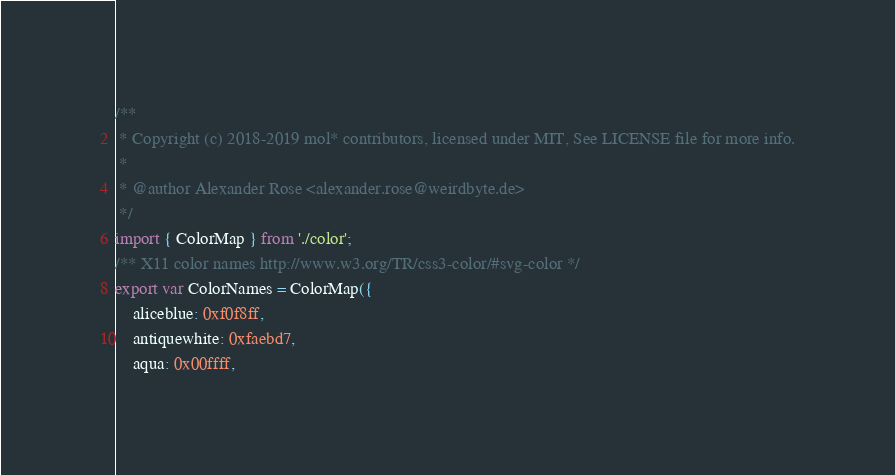Convert code to text. <code><loc_0><loc_0><loc_500><loc_500><_JavaScript_>/**
 * Copyright (c) 2018-2019 mol* contributors, licensed under MIT, See LICENSE file for more info.
 *
 * @author Alexander Rose <alexander.rose@weirdbyte.de>
 */
import { ColorMap } from './color';
/** X11 color names http://www.w3.org/TR/css3-color/#svg-color */
export var ColorNames = ColorMap({
    aliceblue: 0xf0f8ff,
    antiquewhite: 0xfaebd7,
    aqua: 0x00ffff,</code> 